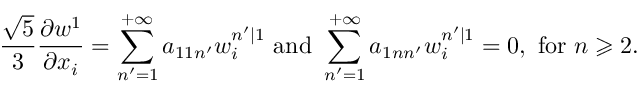Convert formula to latex. <formula><loc_0><loc_0><loc_500><loc_500>\frac { \sqrt { 5 } } { 3 } \frac { \partial w ^ { 1 } } { \partial x _ { i } } = \sum _ { n ^ { \prime } = 1 } ^ { + \infty } a _ { 1 1 n ^ { \prime } } w _ { i } ^ { n ^ { \prime } | 1 } a n d \sum _ { n ^ { \prime } = 1 } ^ { + \infty } a _ { 1 n n ^ { \prime } } w _ { i } ^ { n ^ { \prime } | 1 } = 0 , f o r n \geqslant 2 .</formula> 